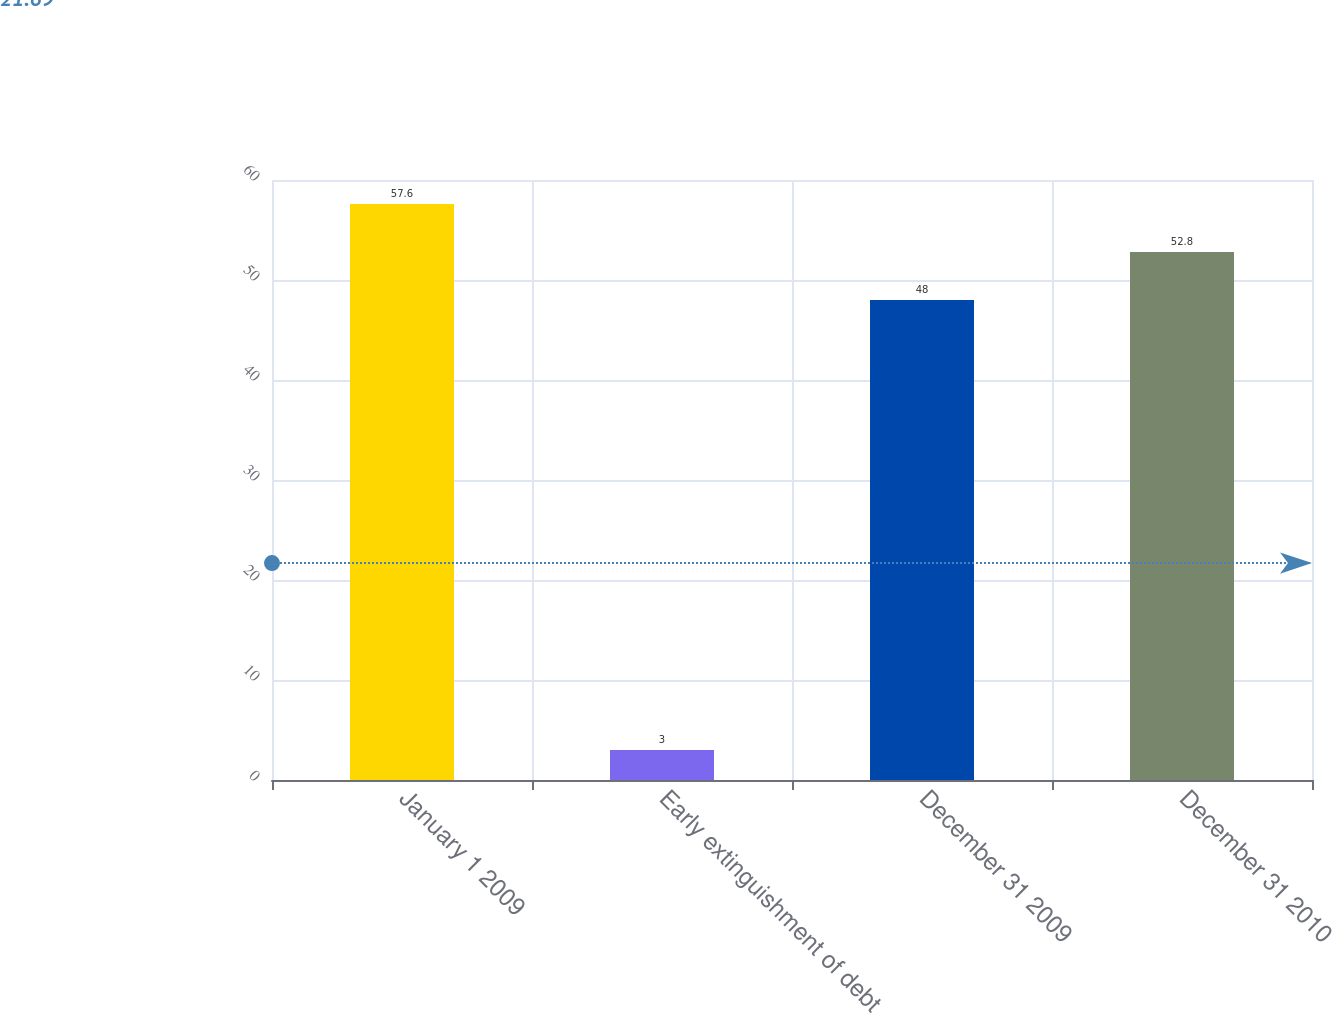Convert chart. <chart><loc_0><loc_0><loc_500><loc_500><bar_chart><fcel>January 1 2009<fcel>Early extinguishment of debt<fcel>December 31 2009<fcel>December 31 2010<nl><fcel>57.6<fcel>3<fcel>48<fcel>52.8<nl></chart> 